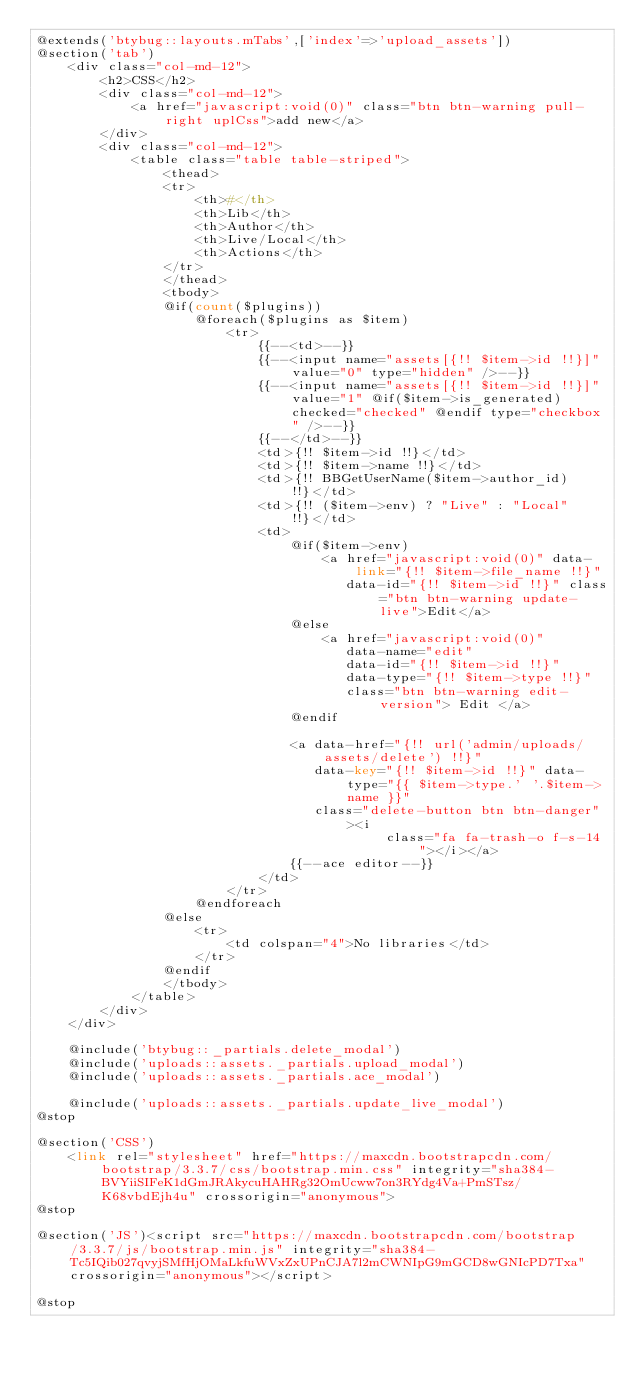Convert code to text. <code><loc_0><loc_0><loc_500><loc_500><_PHP_>@extends('btybug::layouts.mTabs',['index'=>'upload_assets'])
@section('tab')
    <div class="col-md-12">
        <h2>CSS</h2>
        <div class="col-md-12">
            <a href="javascript:void(0)" class="btn btn-warning pull-right uplCss">add new</a>
        </div>
        <div class="col-md-12">
            <table class="table table-striped">
                <thead>
                <tr>
                    <th>#</th>
                    <th>Lib</th>
                    <th>Author</th>
                    <th>Live/Local</th>
                    <th>Actions</th>
                </tr>
                </thead>
                <tbody>
                @if(count($plugins))
                    @foreach($plugins as $item)
                        <tr>
                            {{--<td>--}}
                            {{--<input name="assets[{!! $item->id !!}]" value="0" type="hidden" />--}}
                            {{--<input name="assets[{!! $item->id !!}]" value="1" @if($item->is_generated) checked="checked" @endif type="checkbox" />--}}
                            {{--</td>--}}
                            <td>{!! $item->id !!}</td>
                            <td>{!! $item->name !!}</td>
                            <td>{!! BBGetUserName($item->author_id) !!}</td>
                            <td>{!! ($item->env) ? "Live" : "Local" !!}</td>
                            <td>
                                @if($item->env)
                                    <a href="javascript:void(0)" data-link="{!! $item->file_name !!}"
                                       data-id="{!! $item->id !!}" class="btn btn-warning update-live">Edit</a>
                                @else
                                    <a href="javascript:void(0)"
                                       data-name="edit"
                                       data-id="{!! $item->id !!}"
                                       data-type="{!! $item->type !!}"
                                       class="btn btn-warning edit-version"> Edit </a>
                                @endif

                                <a data-href="{!! url('admin/uploads/assets/delete') !!}"
                                   data-key="{!! $item->id !!}" data-type="{{ $item->type.' '.$item->name }}"
                                   class="delete-button btn btn-danger"><i
                                            class="fa fa-trash-o f-s-14 "></i></a>
                                {{--ace editor--}}
                            </td>
                        </tr>
                    @endforeach
                @else
                    <tr>
                        <td colspan="4">No libraries</td>
                    </tr>
                @endif
                </tbody>
            </table>
        </div>
    </div>

    @include('btybug::_partials.delete_modal')
    @include('uploads::assets._partials.upload_modal')
    @include('uploads::assets._partials.ace_modal')

    @include('uploads::assets._partials.update_live_modal')
@stop

@section('CSS')
    <link rel="stylesheet" href="https://maxcdn.bootstrapcdn.com/bootstrap/3.3.7/css/bootstrap.min.css" integrity="sha384-BVYiiSIFeK1dGmJRAkycuHAHRg32OmUcww7on3RYdg4Va+PmSTsz/K68vbdEjh4u" crossorigin="anonymous">
@stop

@section('JS')<script src="https://maxcdn.bootstrapcdn.com/bootstrap/3.3.7/js/bootstrap.min.js" integrity="sha384-Tc5IQib027qvyjSMfHjOMaLkfuWVxZxUPnCJA7l2mCWNIpG9mGCD8wGNIcPD7Txa" crossorigin="anonymous"></script>

@stop</code> 